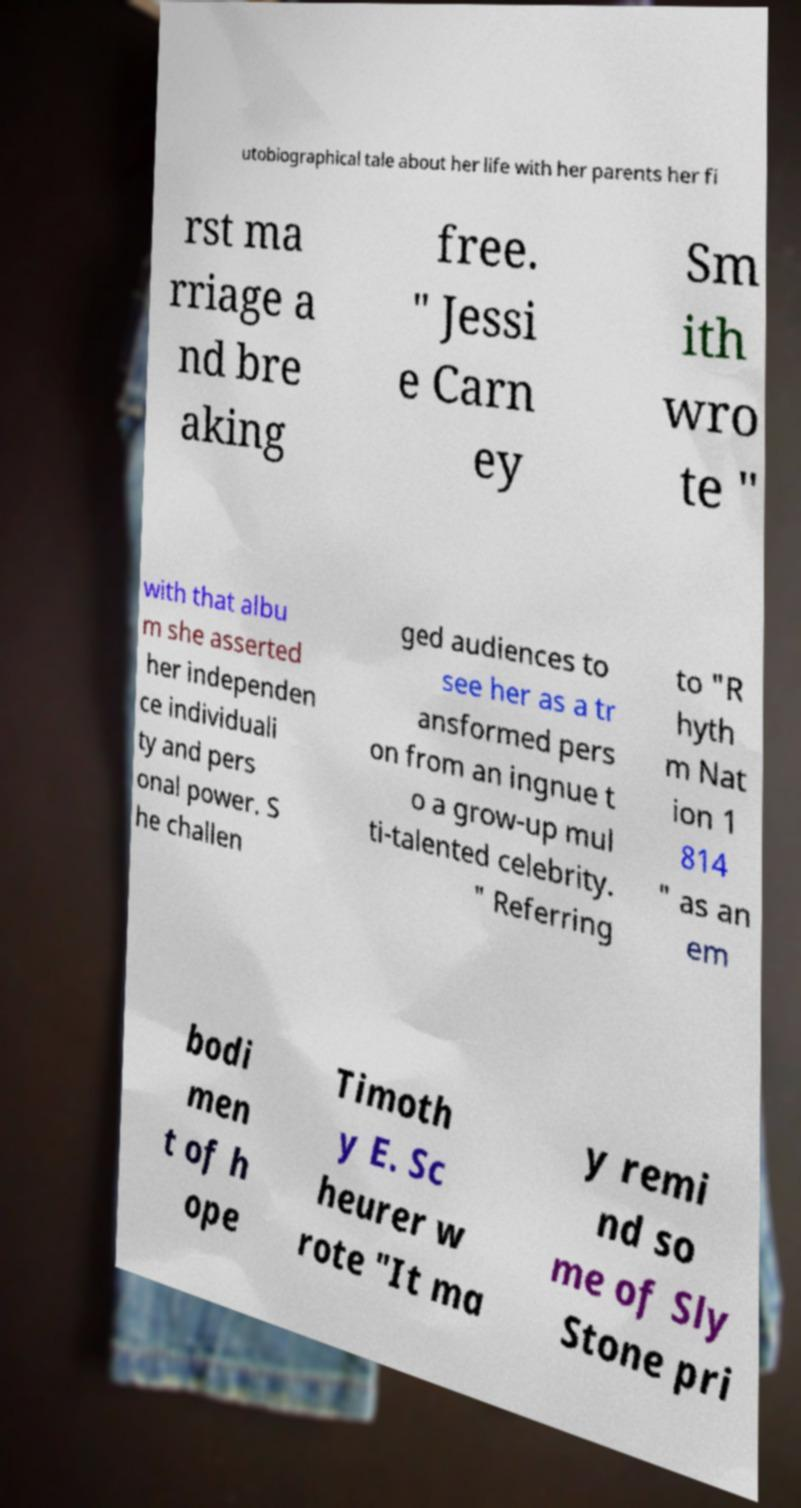There's text embedded in this image that I need extracted. Can you transcribe it verbatim? utobiographical tale about her life with her parents her fi rst ma rriage a nd bre aking free. " Jessi e Carn ey Sm ith wro te " with that albu m she asserted her independen ce individuali ty and pers onal power. S he challen ged audiences to see her as a tr ansformed pers on from an ingnue t o a grow-up mul ti-talented celebrity. " Referring to "R hyth m Nat ion 1 814 " as an em bodi men t of h ope Timoth y E. Sc heurer w rote "It ma y remi nd so me of Sly Stone pri 